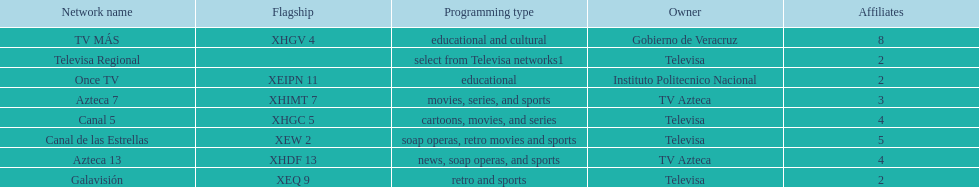Tell me the number of stations tv azteca owns. 2. 